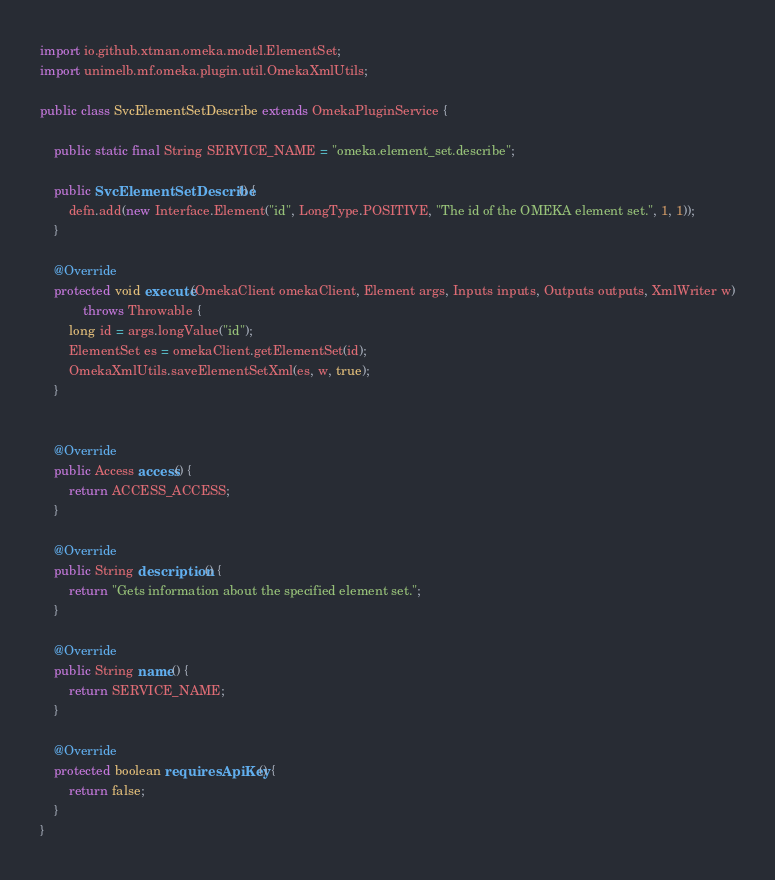Convert code to text. <code><loc_0><loc_0><loc_500><loc_500><_Java_>import io.github.xtman.omeka.model.ElementSet;
import unimelb.mf.omeka.plugin.util.OmekaXmlUtils;

public class SvcElementSetDescribe extends OmekaPluginService {

    public static final String SERVICE_NAME = "omeka.element_set.describe";

    public SvcElementSetDescribe() {
        defn.add(new Interface.Element("id", LongType.POSITIVE, "The id of the OMEKA element set.", 1, 1));
    }

    @Override
    protected void execute(OmekaClient omekaClient, Element args, Inputs inputs, Outputs outputs, XmlWriter w)
            throws Throwable {
        long id = args.longValue("id");
        ElementSet es = omekaClient.getElementSet(id);
        OmekaXmlUtils.saveElementSetXml(es, w, true);
    }


    @Override
    public Access access() {
        return ACCESS_ACCESS;
    }

    @Override
    public String description() {
        return "Gets information about the specified element set.";
    }

    @Override
    public String name() {
        return SERVICE_NAME;
    }

    @Override
    protected boolean requiresApiKey() {
        return false;
    }
}
</code> 